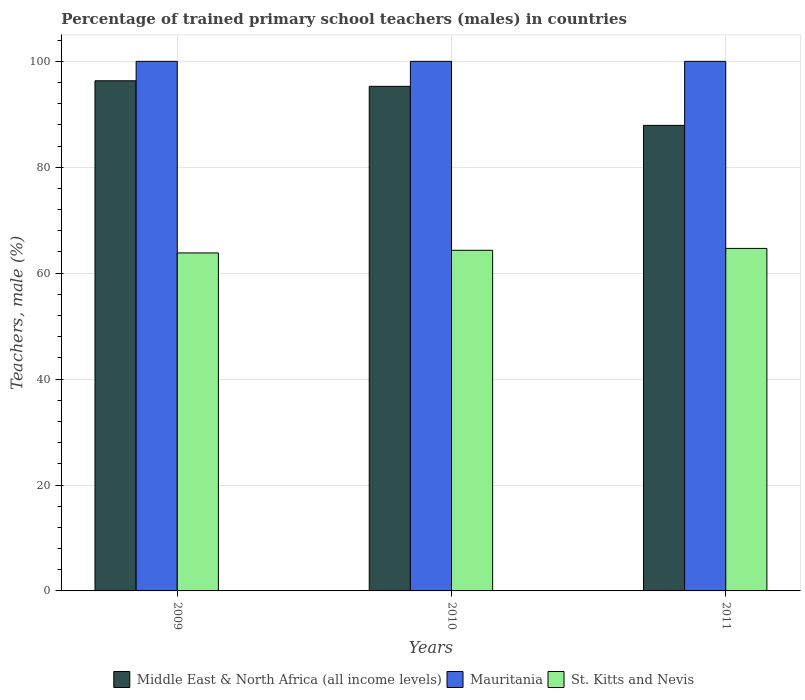How many groups of bars are there?
Your answer should be compact. 3. Are the number of bars per tick equal to the number of legend labels?
Your answer should be very brief. Yes. Are the number of bars on each tick of the X-axis equal?
Ensure brevity in your answer.  Yes. How many bars are there on the 3rd tick from the left?
Offer a very short reply. 3. What is the percentage of trained primary school teachers (males) in St. Kitts and Nevis in 2009?
Keep it short and to the point. 63.82. Across all years, what is the maximum percentage of trained primary school teachers (males) in St. Kitts and Nevis?
Your response must be concise. 64.68. Across all years, what is the minimum percentage of trained primary school teachers (males) in St. Kitts and Nevis?
Give a very brief answer. 63.82. What is the total percentage of trained primary school teachers (males) in St. Kitts and Nevis in the graph?
Provide a succinct answer. 192.82. What is the difference between the percentage of trained primary school teachers (males) in St. Kitts and Nevis in 2010 and that in 2011?
Ensure brevity in your answer.  -0.35. What is the difference between the percentage of trained primary school teachers (males) in Mauritania in 2010 and the percentage of trained primary school teachers (males) in Middle East & North Africa (all income levels) in 2009?
Your answer should be very brief. 3.67. What is the average percentage of trained primary school teachers (males) in Mauritania per year?
Provide a short and direct response. 100. In the year 2009, what is the difference between the percentage of trained primary school teachers (males) in Mauritania and percentage of trained primary school teachers (males) in Middle East & North Africa (all income levels)?
Offer a terse response. 3.67. What is the ratio of the percentage of trained primary school teachers (males) in Middle East & North Africa (all income levels) in 2009 to that in 2011?
Keep it short and to the point. 1.1. Is the difference between the percentage of trained primary school teachers (males) in Mauritania in 2010 and 2011 greater than the difference between the percentage of trained primary school teachers (males) in Middle East & North Africa (all income levels) in 2010 and 2011?
Keep it short and to the point. No. What is the difference between the highest and the second highest percentage of trained primary school teachers (males) in Mauritania?
Provide a short and direct response. 0. What does the 3rd bar from the left in 2011 represents?
Offer a very short reply. St. Kitts and Nevis. What does the 2nd bar from the right in 2009 represents?
Offer a terse response. Mauritania. How many bars are there?
Offer a terse response. 9. Are all the bars in the graph horizontal?
Provide a succinct answer. No. What is the difference between two consecutive major ticks on the Y-axis?
Provide a short and direct response. 20. Are the values on the major ticks of Y-axis written in scientific E-notation?
Your answer should be compact. No. Does the graph contain any zero values?
Your response must be concise. No. How many legend labels are there?
Provide a succinct answer. 3. How are the legend labels stacked?
Provide a succinct answer. Horizontal. What is the title of the graph?
Your response must be concise. Percentage of trained primary school teachers (males) in countries. What is the label or title of the X-axis?
Provide a succinct answer. Years. What is the label or title of the Y-axis?
Give a very brief answer. Teachers, male (%). What is the Teachers, male (%) in Middle East & North Africa (all income levels) in 2009?
Provide a succinct answer. 96.33. What is the Teachers, male (%) in Mauritania in 2009?
Offer a terse response. 100. What is the Teachers, male (%) in St. Kitts and Nevis in 2009?
Offer a terse response. 63.82. What is the Teachers, male (%) of Middle East & North Africa (all income levels) in 2010?
Give a very brief answer. 95.28. What is the Teachers, male (%) of St. Kitts and Nevis in 2010?
Offer a very short reply. 64.32. What is the Teachers, male (%) in Middle East & North Africa (all income levels) in 2011?
Offer a very short reply. 87.91. What is the Teachers, male (%) in St. Kitts and Nevis in 2011?
Your response must be concise. 64.68. Across all years, what is the maximum Teachers, male (%) in Middle East & North Africa (all income levels)?
Make the answer very short. 96.33. Across all years, what is the maximum Teachers, male (%) of St. Kitts and Nevis?
Ensure brevity in your answer.  64.68. Across all years, what is the minimum Teachers, male (%) in Middle East & North Africa (all income levels)?
Your answer should be compact. 87.91. Across all years, what is the minimum Teachers, male (%) in St. Kitts and Nevis?
Make the answer very short. 63.82. What is the total Teachers, male (%) in Middle East & North Africa (all income levels) in the graph?
Provide a succinct answer. 279.53. What is the total Teachers, male (%) in Mauritania in the graph?
Give a very brief answer. 300. What is the total Teachers, male (%) in St. Kitts and Nevis in the graph?
Your answer should be compact. 192.82. What is the difference between the Teachers, male (%) in Middle East & North Africa (all income levels) in 2009 and that in 2010?
Make the answer very short. 1.05. What is the difference between the Teachers, male (%) in St. Kitts and Nevis in 2009 and that in 2010?
Make the answer very short. -0.5. What is the difference between the Teachers, male (%) in Middle East & North Africa (all income levels) in 2009 and that in 2011?
Provide a short and direct response. 8.42. What is the difference between the Teachers, male (%) in St. Kitts and Nevis in 2009 and that in 2011?
Offer a terse response. -0.85. What is the difference between the Teachers, male (%) of Middle East & North Africa (all income levels) in 2010 and that in 2011?
Ensure brevity in your answer.  7.37. What is the difference between the Teachers, male (%) in St. Kitts and Nevis in 2010 and that in 2011?
Keep it short and to the point. -0.35. What is the difference between the Teachers, male (%) of Middle East & North Africa (all income levels) in 2009 and the Teachers, male (%) of Mauritania in 2010?
Your answer should be very brief. -3.67. What is the difference between the Teachers, male (%) of Middle East & North Africa (all income levels) in 2009 and the Teachers, male (%) of St. Kitts and Nevis in 2010?
Make the answer very short. 32.01. What is the difference between the Teachers, male (%) in Mauritania in 2009 and the Teachers, male (%) in St. Kitts and Nevis in 2010?
Your answer should be very brief. 35.68. What is the difference between the Teachers, male (%) of Middle East & North Africa (all income levels) in 2009 and the Teachers, male (%) of Mauritania in 2011?
Offer a very short reply. -3.67. What is the difference between the Teachers, male (%) in Middle East & North Africa (all income levels) in 2009 and the Teachers, male (%) in St. Kitts and Nevis in 2011?
Ensure brevity in your answer.  31.66. What is the difference between the Teachers, male (%) of Mauritania in 2009 and the Teachers, male (%) of St. Kitts and Nevis in 2011?
Offer a terse response. 35.32. What is the difference between the Teachers, male (%) in Middle East & North Africa (all income levels) in 2010 and the Teachers, male (%) in Mauritania in 2011?
Ensure brevity in your answer.  -4.72. What is the difference between the Teachers, male (%) in Middle East & North Africa (all income levels) in 2010 and the Teachers, male (%) in St. Kitts and Nevis in 2011?
Your answer should be compact. 30.61. What is the difference between the Teachers, male (%) of Mauritania in 2010 and the Teachers, male (%) of St. Kitts and Nevis in 2011?
Provide a succinct answer. 35.32. What is the average Teachers, male (%) of Middle East & North Africa (all income levels) per year?
Your answer should be very brief. 93.18. What is the average Teachers, male (%) of Mauritania per year?
Provide a succinct answer. 100. What is the average Teachers, male (%) in St. Kitts and Nevis per year?
Your answer should be very brief. 64.27. In the year 2009, what is the difference between the Teachers, male (%) in Middle East & North Africa (all income levels) and Teachers, male (%) in Mauritania?
Offer a terse response. -3.67. In the year 2009, what is the difference between the Teachers, male (%) in Middle East & North Africa (all income levels) and Teachers, male (%) in St. Kitts and Nevis?
Your answer should be compact. 32.51. In the year 2009, what is the difference between the Teachers, male (%) in Mauritania and Teachers, male (%) in St. Kitts and Nevis?
Provide a succinct answer. 36.18. In the year 2010, what is the difference between the Teachers, male (%) of Middle East & North Africa (all income levels) and Teachers, male (%) of Mauritania?
Provide a short and direct response. -4.72. In the year 2010, what is the difference between the Teachers, male (%) in Middle East & North Africa (all income levels) and Teachers, male (%) in St. Kitts and Nevis?
Ensure brevity in your answer.  30.96. In the year 2010, what is the difference between the Teachers, male (%) of Mauritania and Teachers, male (%) of St. Kitts and Nevis?
Ensure brevity in your answer.  35.68. In the year 2011, what is the difference between the Teachers, male (%) of Middle East & North Africa (all income levels) and Teachers, male (%) of Mauritania?
Your answer should be compact. -12.09. In the year 2011, what is the difference between the Teachers, male (%) of Middle East & North Africa (all income levels) and Teachers, male (%) of St. Kitts and Nevis?
Provide a succinct answer. 23.24. In the year 2011, what is the difference between the Teachers, male (%) of Mauritania and Teachers, male (%) of St. Kitts and Nevis?
Offer a very short reply. 35.32. What is the ratio of the Teachers, male (%) in Middle East & North Africa (all income levels) in 2009 to that in 2011?
Your answer should be very brief. 1.1. What is the ratio of the Teachers, male (%) in Mauritania in 2009 to that in 2011?
Your response must be concise. 1. What is the ratio of the Teachers, male (%) of St. Kitts and Nevis in 2009 to that in 2011?
Provide a short and direct response. 0.99. What is the ratio of the Teachers, male (%) of Middle East & North Africa (all income levels) in 2010 to that in 2011?
Keep it short and to the point. 1.08. What is the ratio of the Teachers, male (%) in St. Kitts and Nevis in 2010 to that in 2011?
Give a very brief answer. 0.99. What is the difference between the highest and the second highest Teachers, male (%) in Middle East & North Africa (all income levels)?
Ensure brevity in your answer.  1.05. What is the difference between the highest and the second highest Teachers, male (%) of Mauritania?
Give a very brief answer. 0. What is the difference between the highest and the second highest Teachers, male (%) in St. Kitts and Nevis?
Give a very brief answer. 0.35. What is the difference between the highest and the lowest Teachers, male (%) of Middle East & North Africa (all income levels)?
Your response must be concise. 8.42. What is the difference between the highest and the lowest Teachers, male (%) in St. Kitts and Nevis?
Offer a terse response. 0.85. 